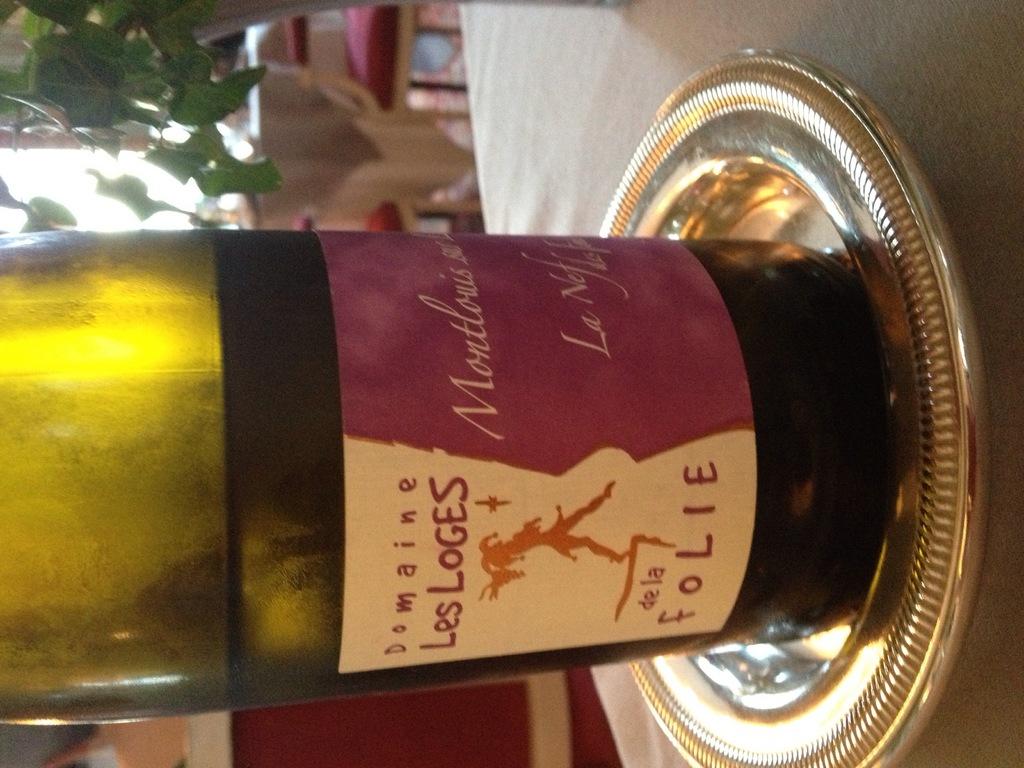Which vinery made this wine?
Offer a very short reply. Domaine les loges. 